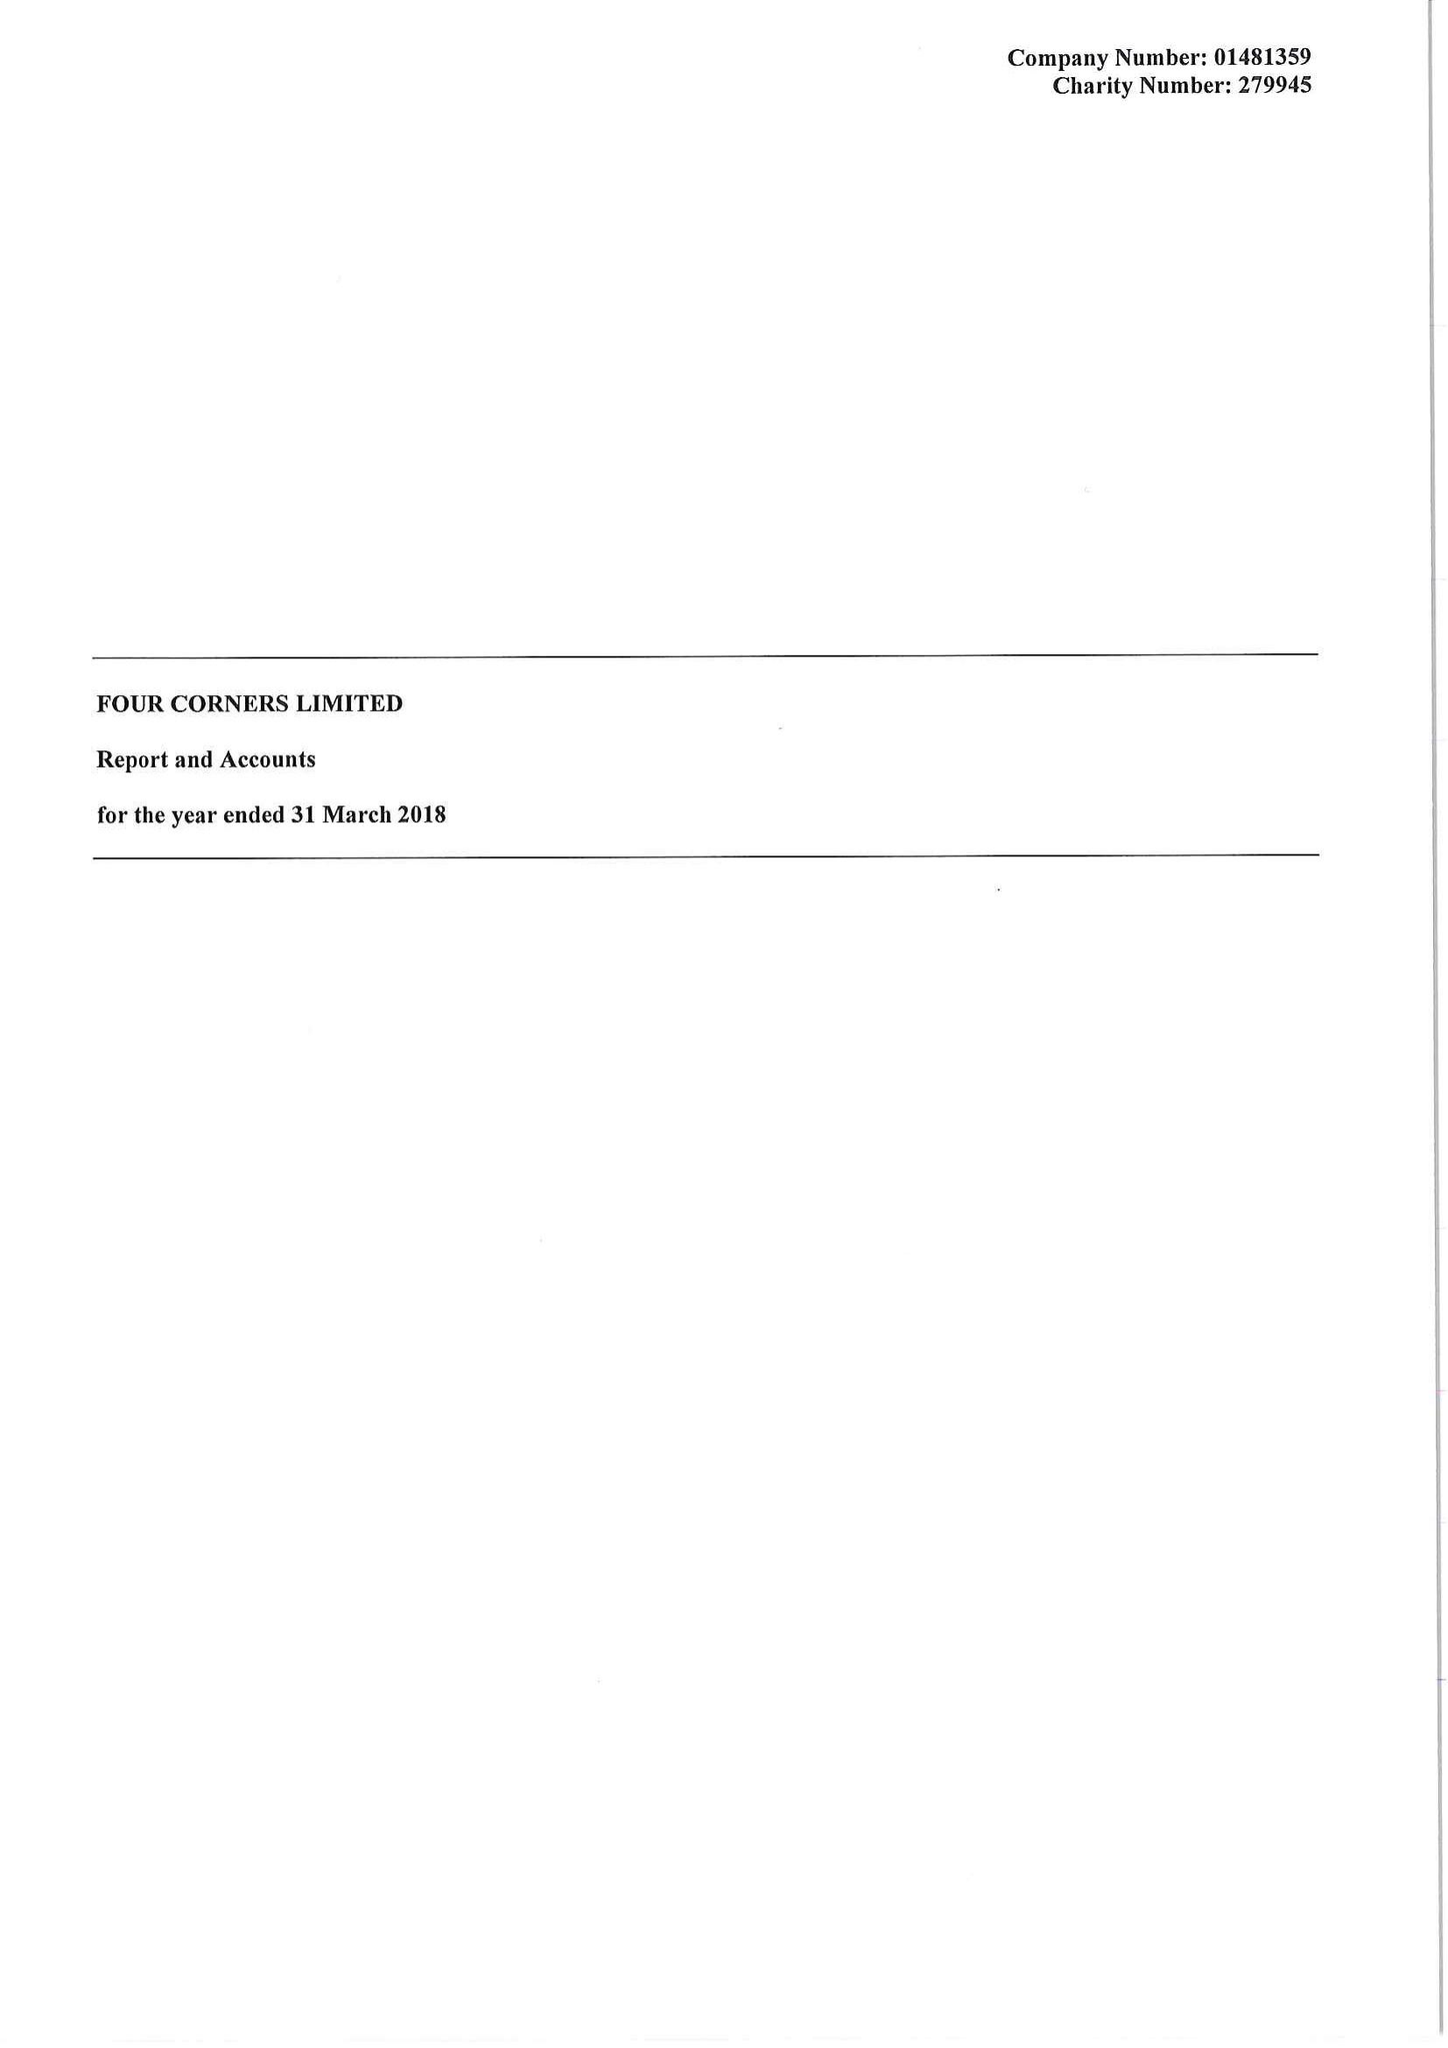What is the value for the report_date?
Answer the question using a single word or phrase. 2018-03-31 